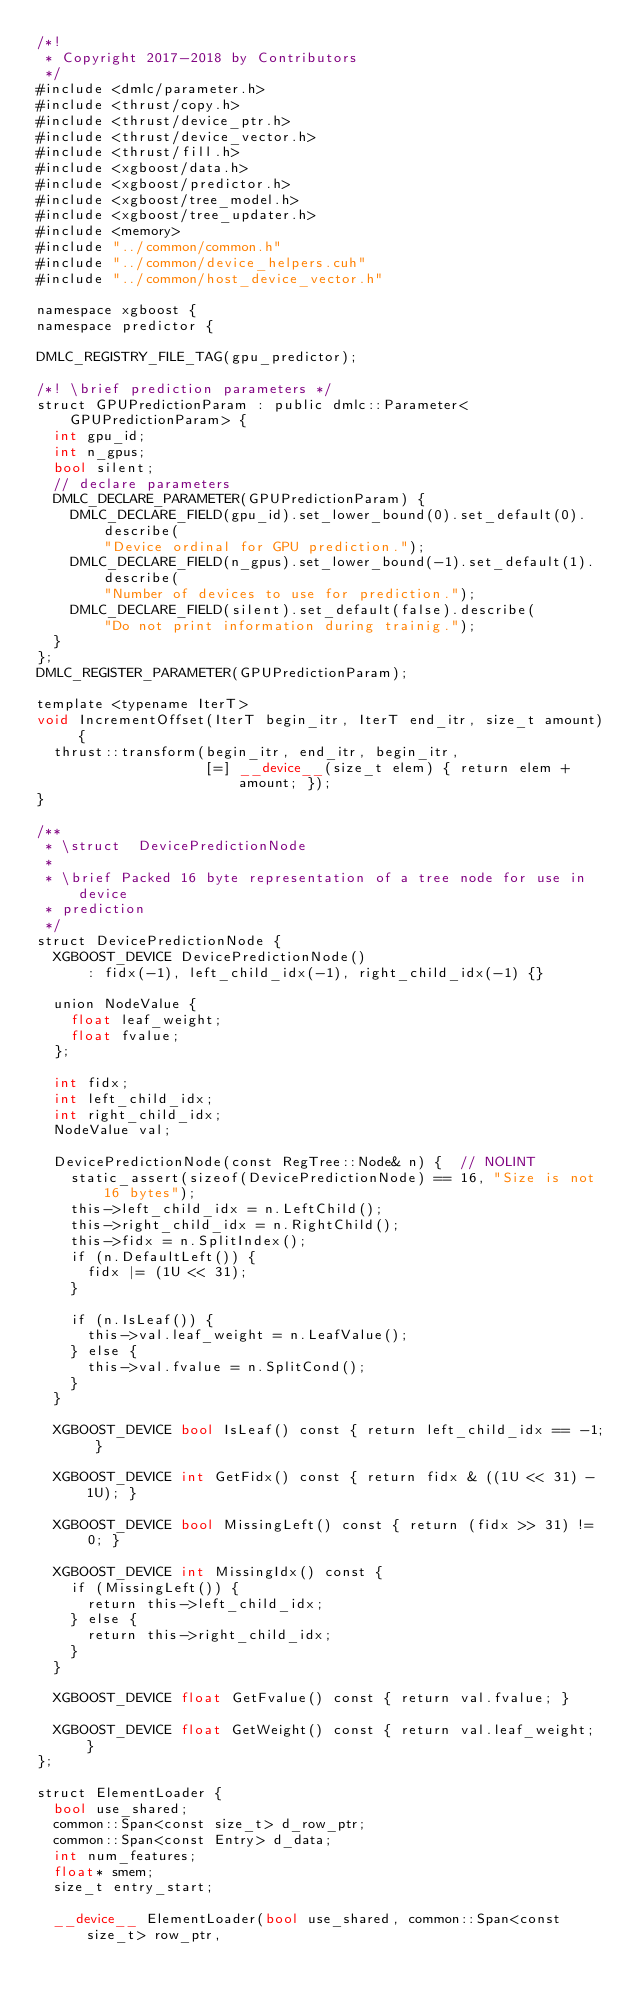Convert code to text. <code><loc_0><loc_0><loc_500><loc_500><_Cuda_>/*!
 * Copyright 2017-2018 by Contributors
 */
#include <dmlc/parameter.h>
#include <thrust/copy.h>
#include <thrust/device_ptr.h>
#include <thrust/device_vector.h>
#include <thrust/fill.h>
#include <xgboost/data.h>
#include <xgboost/predictor.h>
#include <xgboost/tree_model.h>
#include <xgboost/tree_updater.h>
#include <memory>
#include "../common/common.h"
#include "../common/device_helpers.cuh"
#include "../common/host_device_vector.h"

namespace xgboost {
namespace predictor {

DMLC_REGISTRY_FILE_TAG(gpu_predictor);

/*! \brief prediction parameters */
struct GPUPredictionParam : public dmlc::Parameter<GPUPredictionParam> {
  int gpu_id;
  int n_gpus;
  bool silent;
  // declare parameters
  DMLC_DECLARE_PARAMETER(GPUPredictionParam) {
    DMLC_DECLARE_FIELD(gpu_id).set_lower_bound(0).set_default(0).describe(
        "Device ordinal for GPU prediction.");
    DMLC_DECLARE_FIELD(n_gpus).set_lower_bound(-1).set_default(1).describe(
        "Number of devices to use for prediction.");
    DMLC_DECLARE_FIELD(silent).set_default(false).describe(
        "Do not print information during trainig.");
  }
};
DMLC_REGISTER_PARAMETER(GPUPredictionParam);

template <typename IterT>
void IncrementOffset(IterT begin_itr, IterT end_itr, size_t amount) {
  thrust::transform(begin_itr, end_itr, begin_itr,
                    [=] __device__(size_t elem) { return elem + amount; });
}

/**
 * \struct  DevicePredictionNode
 *
 * \brief Packed 16 byte representation of a tree node for use in device
 * prediction
 */
struct DevicePredictionNode {
  XGBOOST_DEVICE DevicePredictionNode()
      : fidx(-1), left_child_idx(-1), right_child_idx(-1) {}

  union NodeValue {
    float leaf_weight;
    float fvalue;
  };

  int fidx;
  int left_child_idx;
  int right_child_idx;
  NodeValue val;

  DevicePredictionNode(const RegTree::Node& n) {  // NOLINT
    static_assert(sizeof(DevicePredictionNode) == 16, "Size is not 16 bytes");
    this->left_child_idx = n.LeftChild();
    this->right_child_idx = n.RightChild();
    this->fidx = n.SplitIndex();
    if (n.DefaultLeft()) {
      fidx |= (1U << 31);
    }

    if (n.IsLeaf()) {
      this->val.leaf_weight = n.LeafValue();
    } else {
      this->val.fvalue = n.SplitCond();
    }
  }

  XGBOOST_DEVICE bool IsLeaf() const { return left_child_idx == -1; }

  XGBOOST_DEVICE int GetFidx() const { return fidx & ((1U << 31) - 1U); }

  XGBOOST_DEVICE bool MissingLeft() const { return (fidx >> 31) != 0; }

  XGBOOST_DEVICE int MissingIdx() const {
    if (MissingLeft()) {
      return this->left_child_idx;
    } else {
      return this->right_child_idx;
    }
  }

  XGBOOST_DEVICE float GetFvalue() const { return val.fvalue; }

  XGBOOST_DEVICE float GetWeight() const { return val.leaf_weight; }
};

struct ElementLoader {
  bool use_shared;
  common::Span<const size_t> d_row_ptr;
  common::Span<const Entry> d_data;
  int num_features;
  float* smem;
  size_t entry_start;

  __device__ ElementLoader(bool use_shared, common::Span<const size_t> row_ptr,</code> 